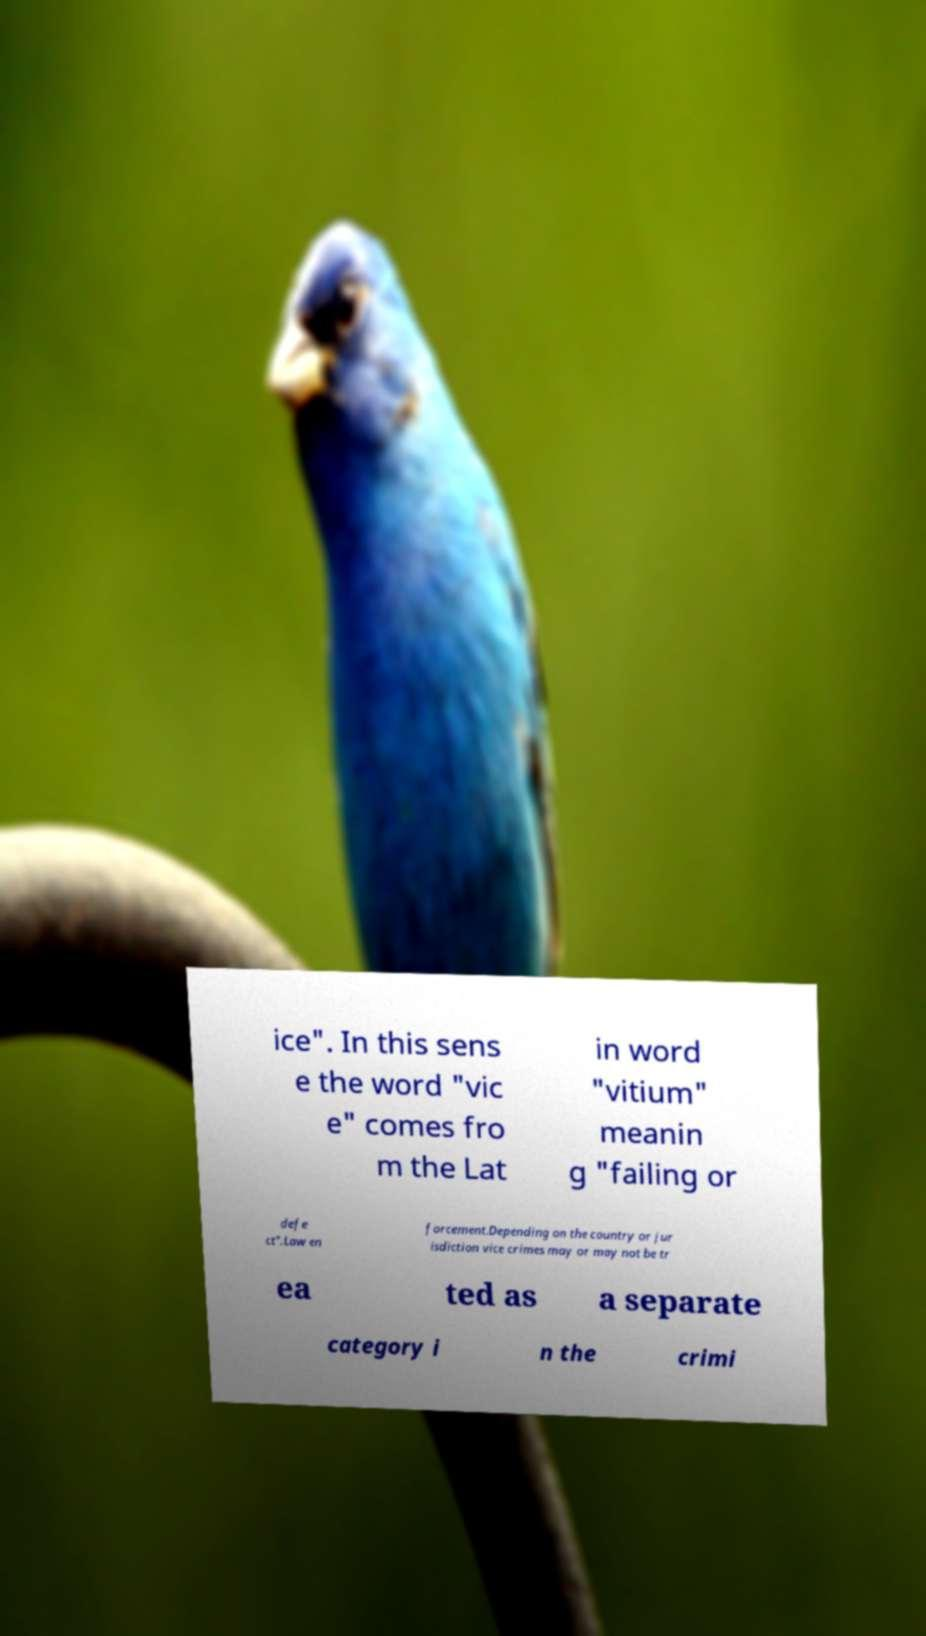Could you extract and type out the text from this image? ice". In this sens e the word "vic e" comes fro m the Lat in word "vitium" meanin g "failing or defe ct".Law en forcement.Depending on the country or jur isdiction vice crimes may or may not be tr ea ted as a separate category i n the crimi 